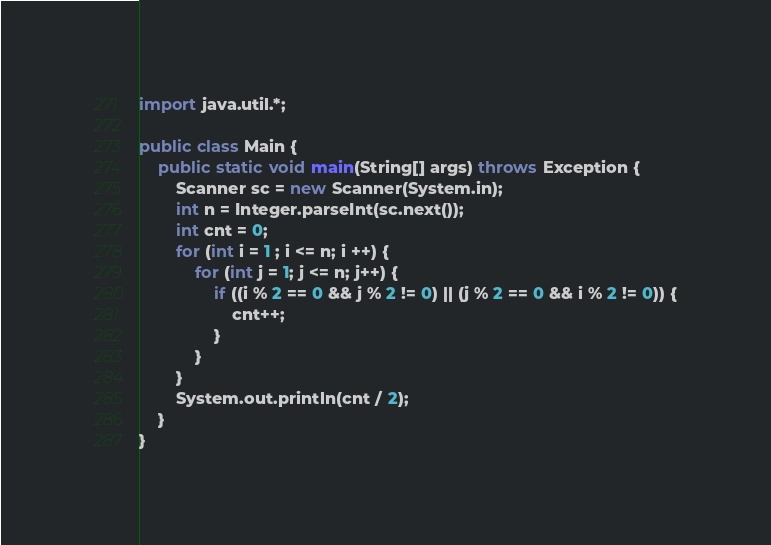Convert code to text. <code><loc_0><loc_0><loc_500><loc_500><_Java_>import java.util.*;

public class Main {
    public static void main(String[] args) throws Exception {
        Scanner sc = new Scanner(System.in);
        int n = Integer.parseInt(sc.next());
        int cnt = 0;
        for (int i = 1 ; i <= n; i ++) {
            for (int j = 1; j <= n; j++) {
                if ((i % 2 == 0 && j % 2 != 0) || (j % 2 == 0 && i % 2 != 0)) {
                    cnt++;
                }
            }
        }
        System.out.println(cnt / 2);
    }
}</code> 